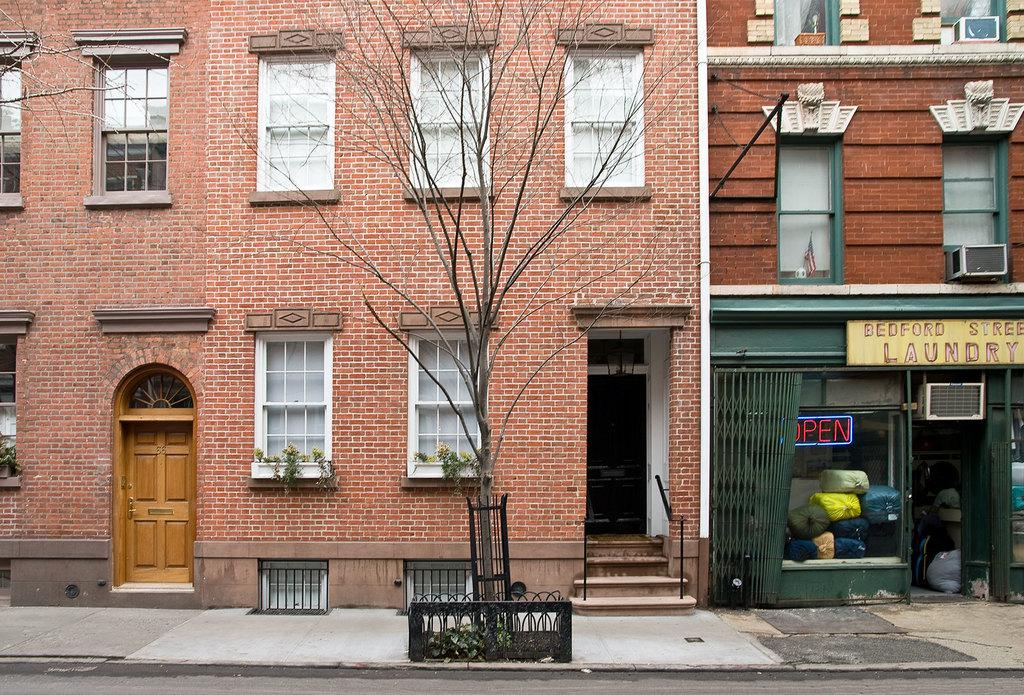What type of structures are present in the image? There are buildings in the image. What feature can be seen on the buildings? The buildings have windows. What type of vegetation is present in the image? There is a tree in the image. What material is visible in the image? There is glass visible in the image. Can you hear the kitty crying while driving in the image? There is no kitty or driving present in the image, so it is not possible to hear any crying. 